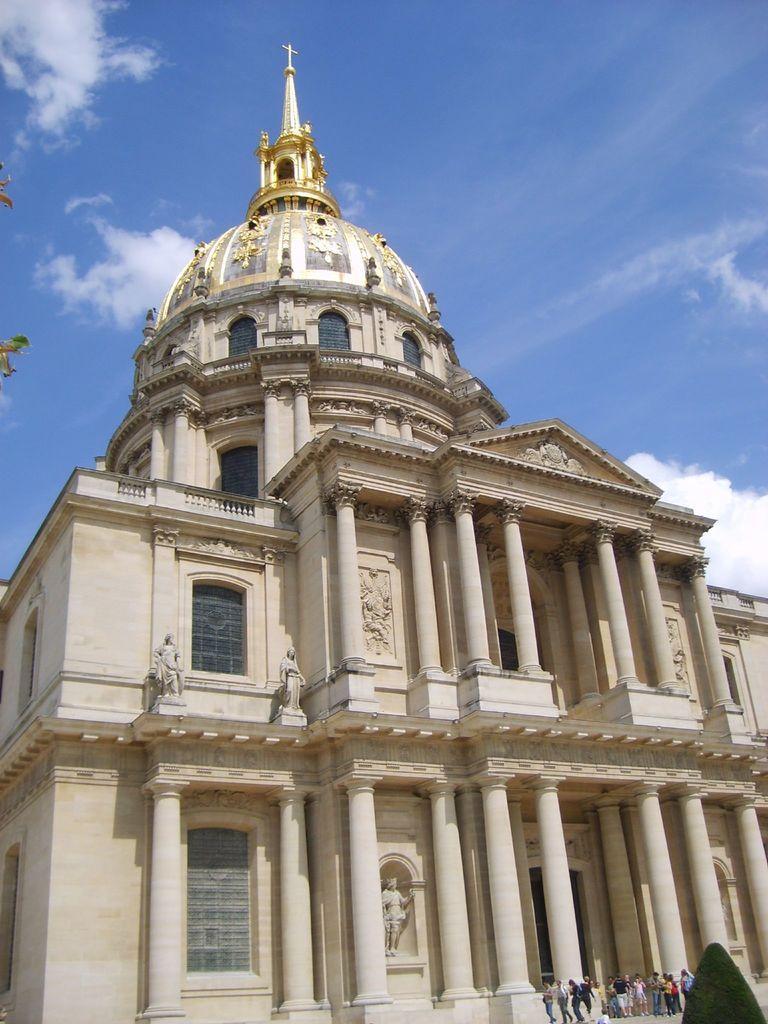How would you summarize this image in a sentence or two? There are people and we can see tree. We can see building, statues and pillars. On the left side of the image we can see leaves. In the background we can see sky with clouds. 